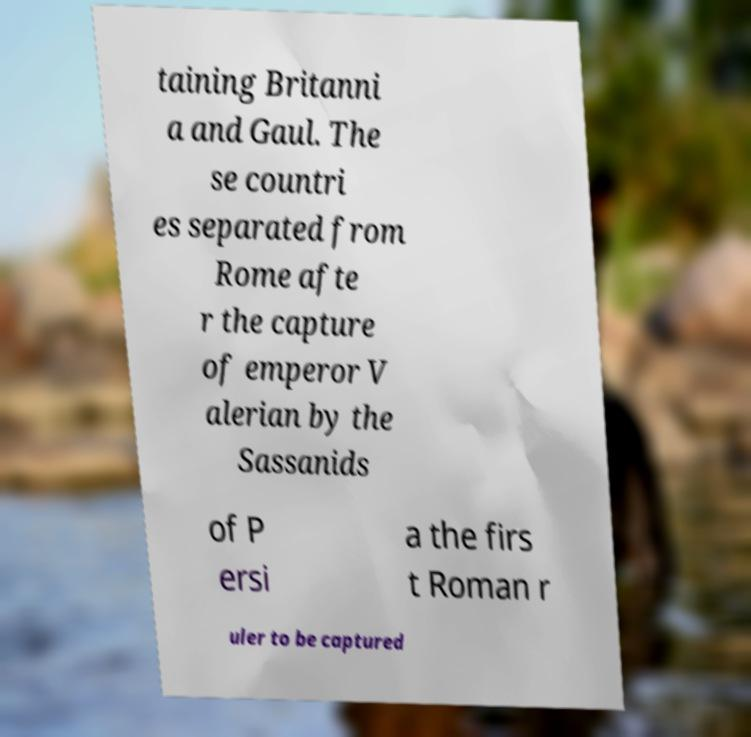Please read and relay the text visible in this image. What does it say? taining Britanni a and Gaul. The se countri es separated from Rome afte r the capture of emperor V alerian by the Sassanids of P ersi a the firs t Roman r uler to be captured 